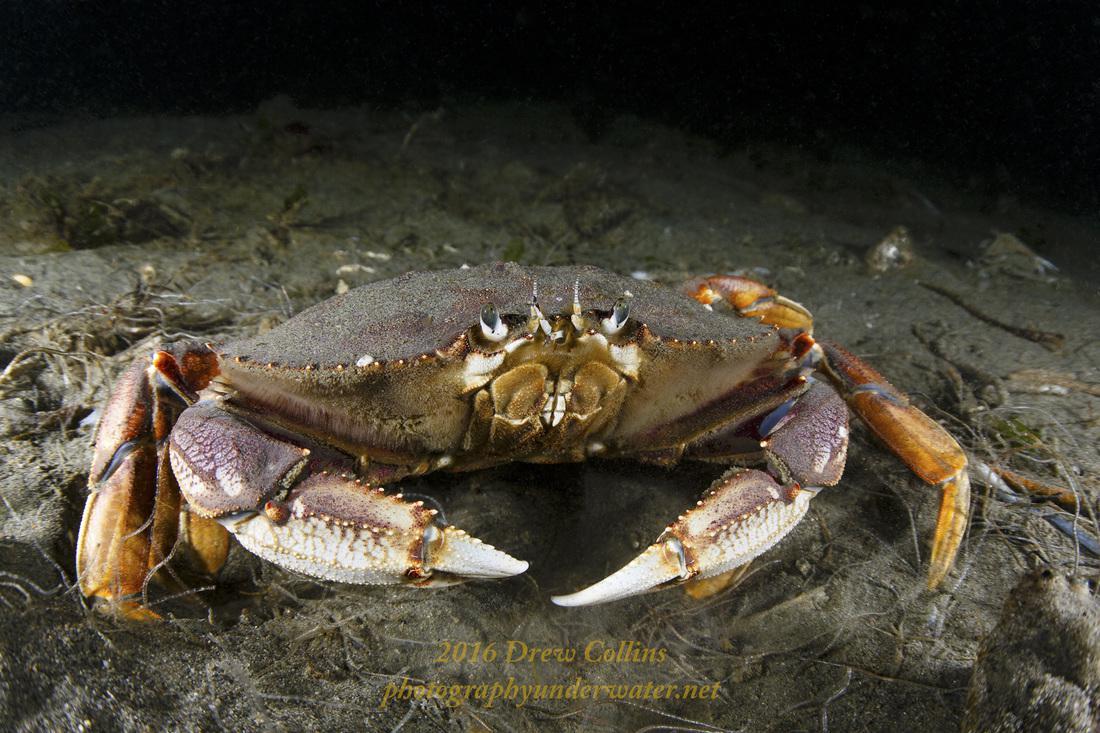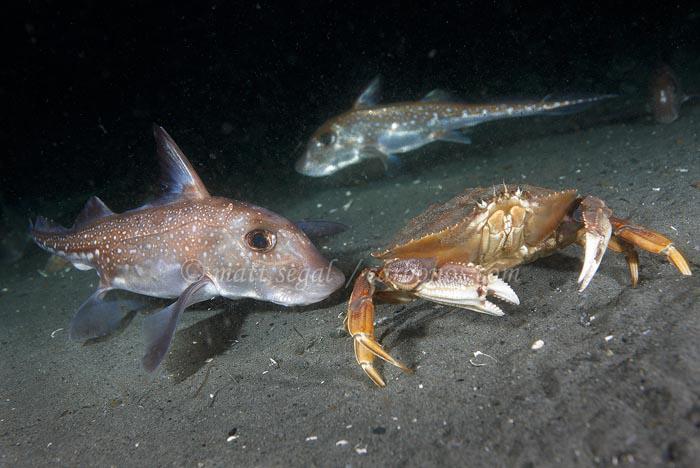The first image is the image on the left, the second image is the image on the right. For the images displayed, is the sentence "The left and right image contains the same number of sea animals." factually correct? Answer yes or no. No. The first image is the image on the left, the second image is the image on the right. Evaluate the accuracy of this statement regarding the images: "Each image contains exactly one prominent forward-facing crab, and no image contains a part of a human.". Is it true? Answer yes or no. Yes. 